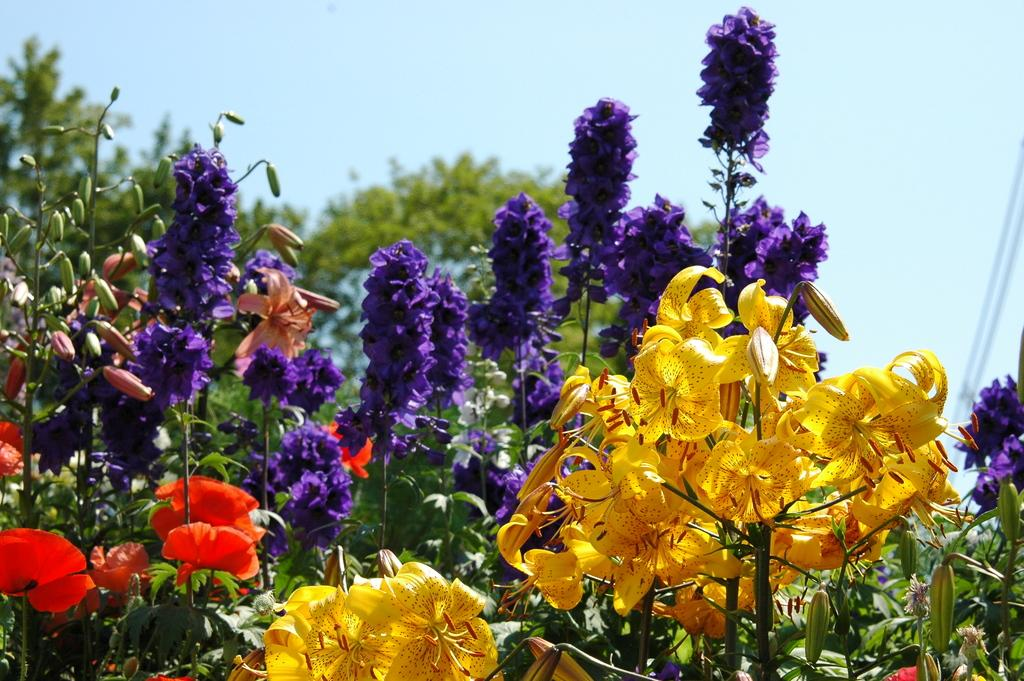What is the main subject of the image? The main subject of the image is planets with different colored flowers in the center. What can be seen in the background of the image? There is a sky visible in the background of the image, and there are also trees present. What is the name of the daughter who made the request for a new month to be added to the calendar? There is no mention of a daughter, request, or new month in the image, so this information cannot be determined. 